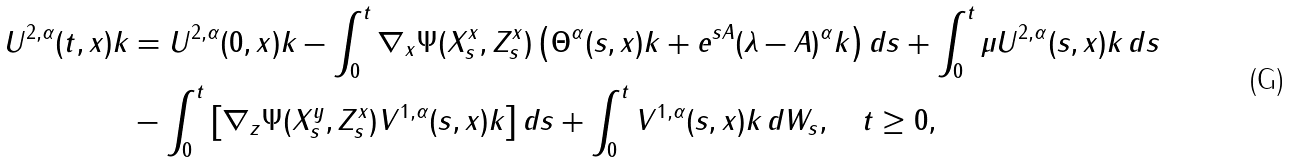Convert formula to latex. <formula><loc_0><loc_0><loc_500><loc_500>U ^ { 2 , \alpha } ( t , x ) k & = U ^ { 2 , \alpha } ( 0 , x ) k - \int _ { 0 } ^ { t } \nabla _ { x } \Psi ( X _ { s } ^ { x } , Z _ { s } ^ { x } ) \left ( \Theta ^ { \alpha } ( s , x ) k + e ^ { s A } ( \lambda - A ) ^ { \alpha } k \right ) d s + \int _ { 0 } ^ { t } \mu U ^ { 2 , \alpha } ( s , x ) k \, d s \\ & - \int _ { 0 } ^ { t } \left [ \nabla _ { z } \Psi ( X _ { s } ^ { y } , Z _ { s } ^ { x } ) V ^ { 1 , \alpha } ( s , x ) k \right ] d s + \int _ { 0 } ^ { t } V ^ { 1 , \alpha } ( s , x ) k \, d W _ { s } , \quad t \geq 0 , \\</formula> 